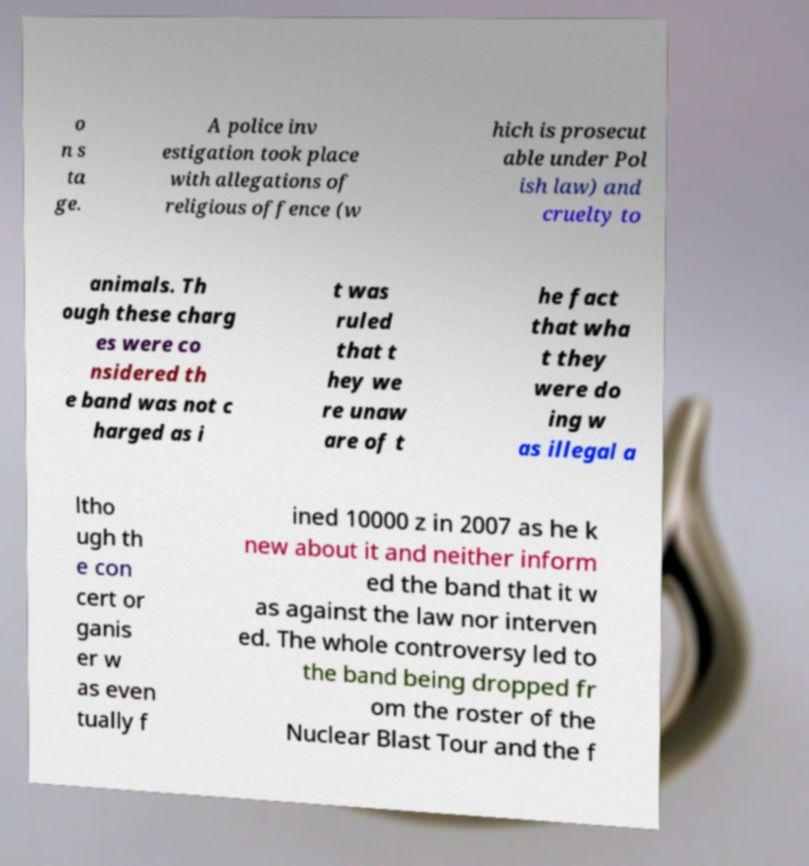Can you read and provide the text displayed in the image?This photo seems to have some interesting text. Can you extract and type it out for me? o n s ta ge. A police inv estigation took place with allegations of religious offence (w hich is prosecut able under Pol ish law) and cruelty to animals. Th ough these charg es were co nsidered th e band was not c harged as i t was ruled that t hey we re unaw are of t he fact that wha t they were do ing w as illegal a ltho ugh th e con cert or ganis er w as even tually f ined 10000 z in 2007 as he k new about it and neither inform ed the band that it w as against the law nor interven ed. The whole controversy led to the band being dropped fr om the roster of the Nuclear Blast Tour and the f 